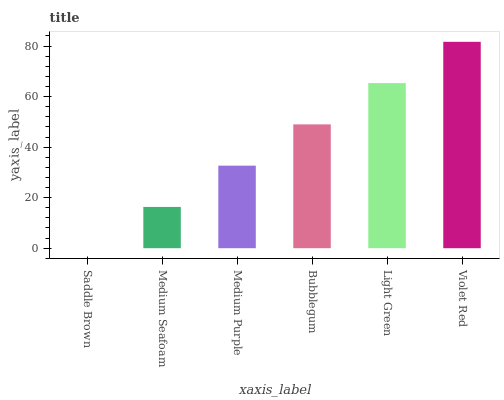Is Medium Seafoam the minimum?
Answer yes or no. No. Is Medium Seafoam the maximum?
Answer yes or no. No. Is Medium Seafoam greater than Saddle Brown?
Answer yes or no. Yes. Is Saddle Brown less than Medium Seafoam?
Answer yes or no. Yes. Is Saddle Brown greater than Medium Seafoam?
Answer yes or no. No. Is Medium Seafoam less than Saddle Brown?
Answer yes or no. No. Is Bubblegum the high median?
Answer yes or no. Yes. Is Medium Purple the low median?
Answer yes or no. Yes. Is Violet Red the high median?
Answer yes or no. No. Is Bubblegum the low median?
Answer yes or no. No. 